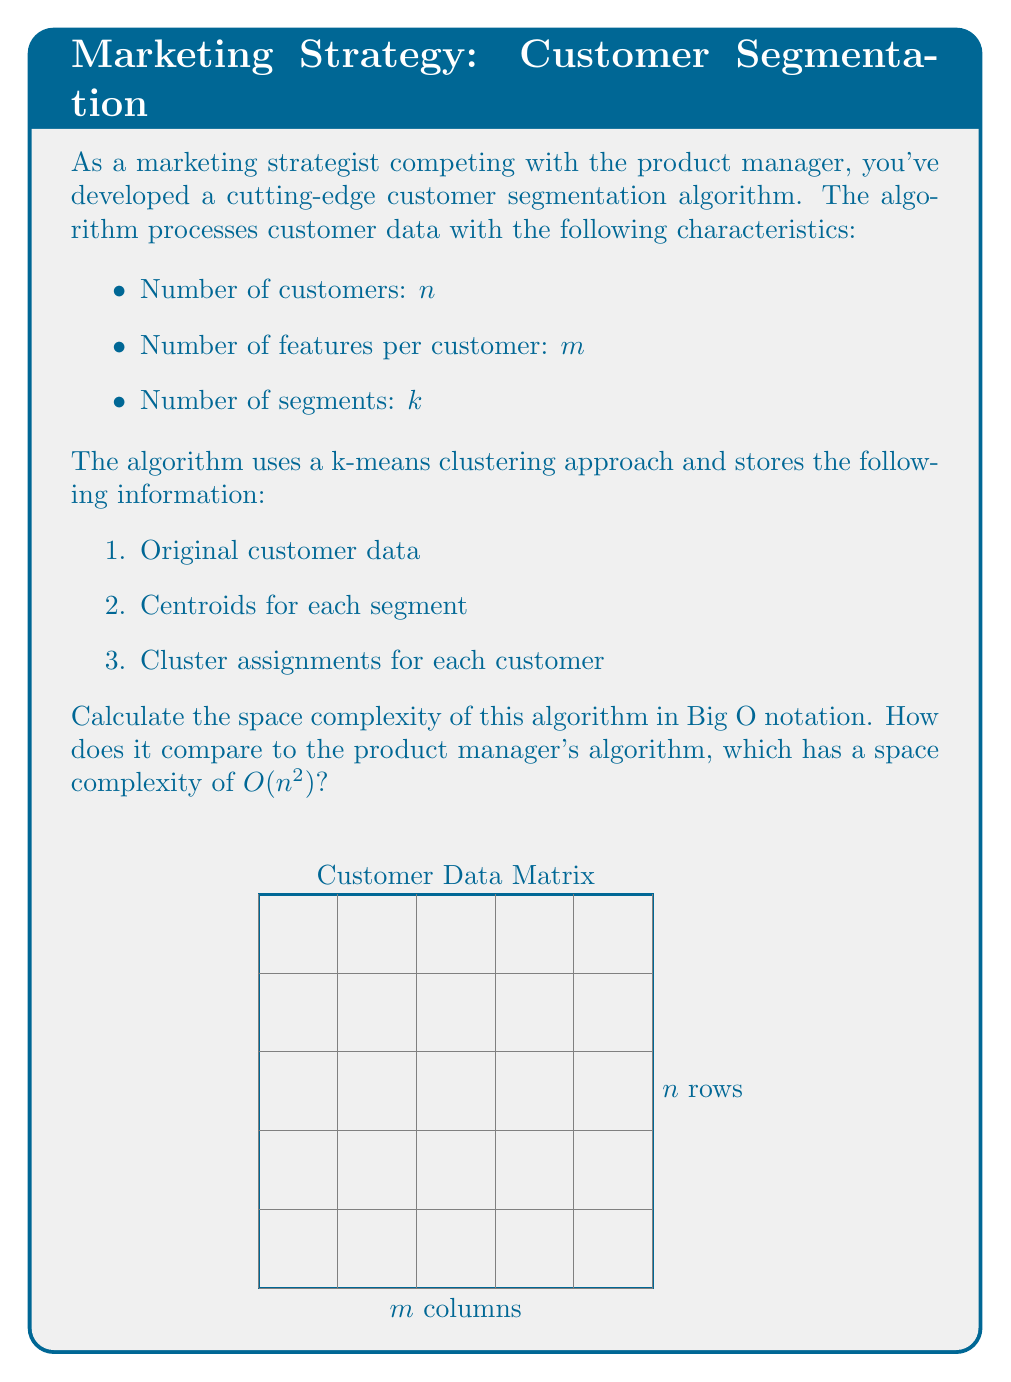Could you help me with this problem? Let's analyze the space complexity step by step:

1. Original customer data:
   - We have $n$ customers, each with $m$ features
   - Space required: $O(n \cdot m)$

2. Centroids for each segment:
   - We have $k$ segments, each centroid has $m$ features
   - Space required: $O(k \cdot m)$

3. Cluster assignments for each customer:
   - We need to store the cluster assignment for each of the $n$ customers
   - Space required: $O(n)$

Total space complexity:
$$O(n \cdot m) + O(k \cdot m) + O(n)$$

Simplifying:
- Since $k < n$ (typically, we have fewer segments than customers), $O(k \cdot m)$ is dominated by $O(n \cdot m)$
- $O(n)$ is also dominated by $O(n \cdot m)$ when $m > 1$

Therefore, the simplified space complexity is $O(n \cdot m)$.

Comparison with the product manager's algorithm:
- Our algorithm: $O(n \cdot m)$
- Product manager's algorithm: $O(n^2)$

Our algorithm is more space-efficient when $m < n$, which is typically the case in customer segmentation problems where the number of features is less than the number of customers.
Answer: $O(n \cdot m)$ 